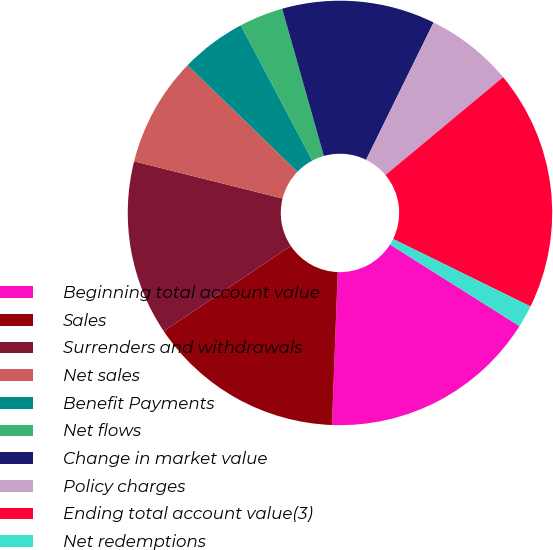Convert chart. <chart><loc_0><loc_0><loc_500><loc_500><pie_chart><fcel>Beginning total account value<fcel>Sales<fcel>Surrenders and withdrawals<fcel>Net sales<fcel>Benefit Payments<fcel>Net flows<fcel>Change in market value<fcel>Policy charges<fcel>Ending total account value(3)<fcel>Net redemptions<nl><fcel>16.65%<fcel>14.99%<fcel>13.32%<fcel>8.34%<fcel>5.01%<fcel>3.35%<fcel>11.66%<fcel>6.68%<fcel>18.31%<fcel>1.69%<nl></chart> 